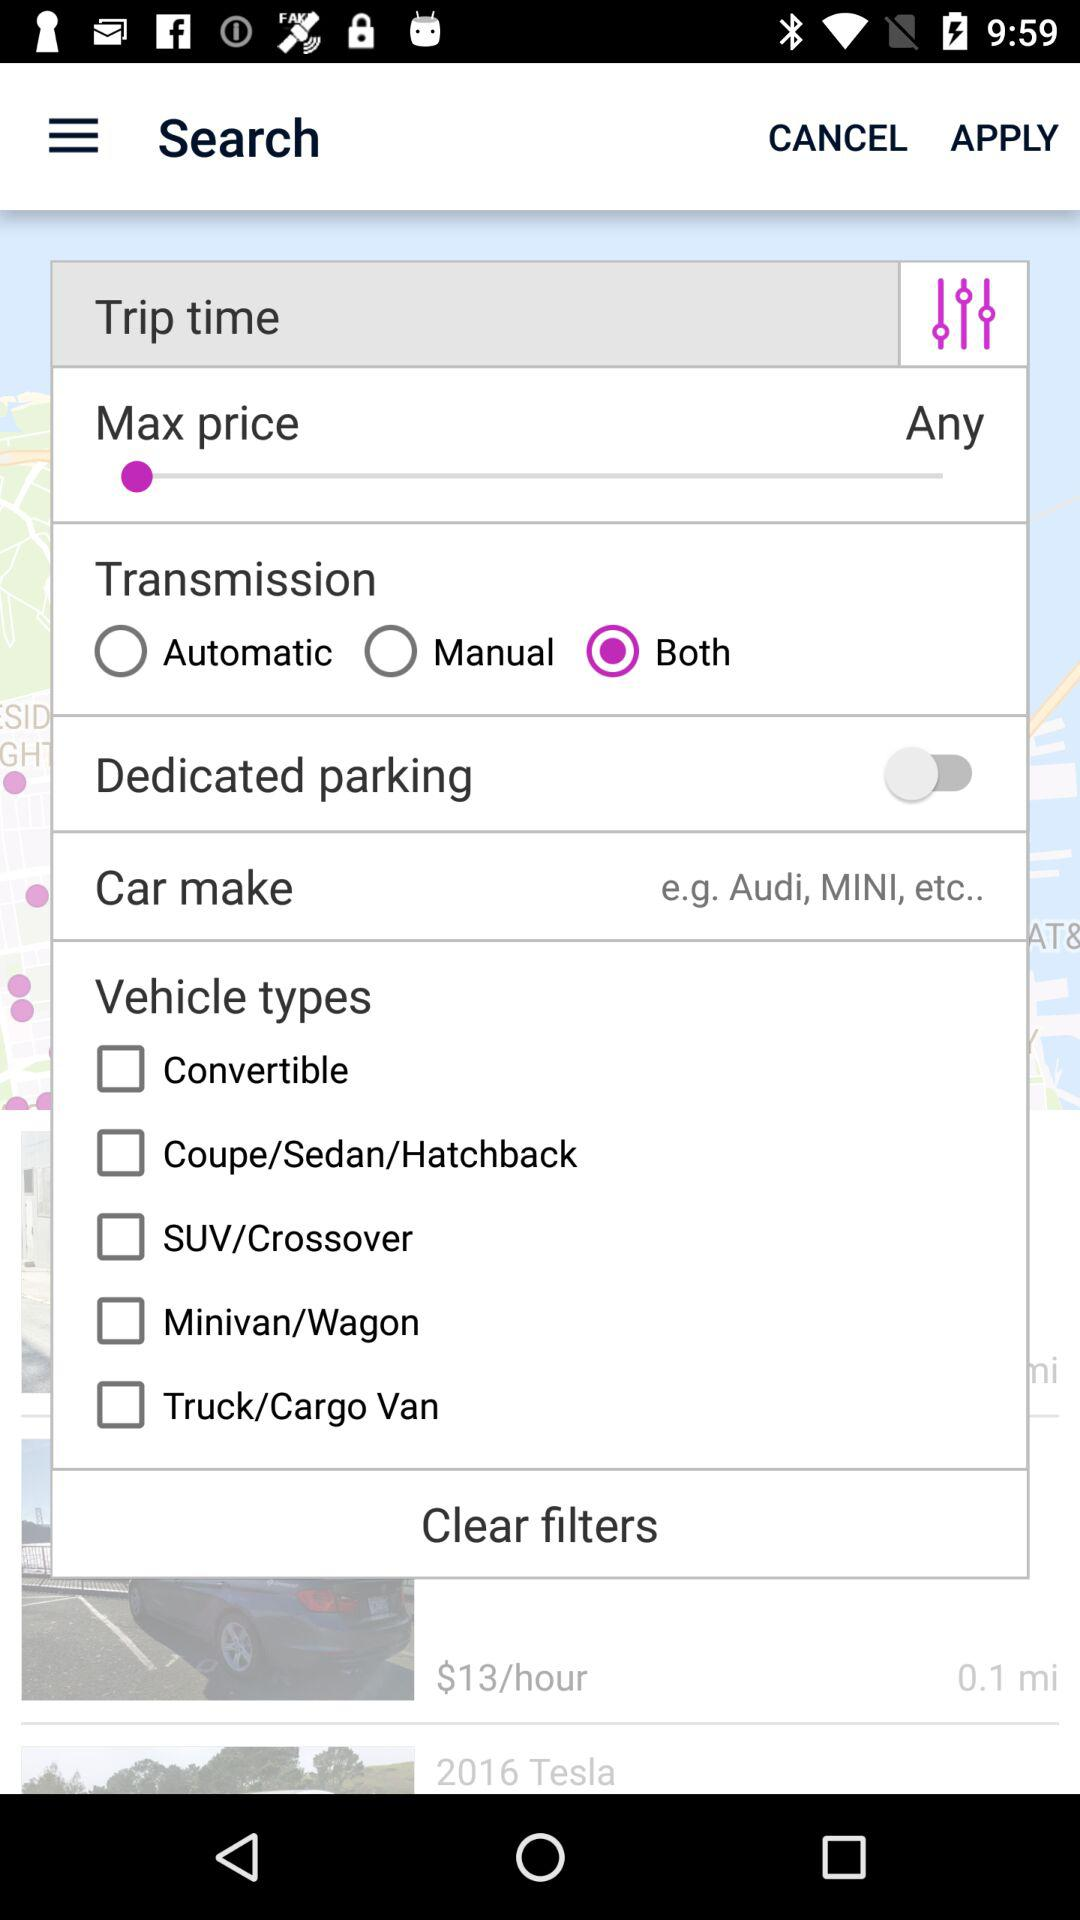What is the status of "Dedicated parking"? The status is "off". 